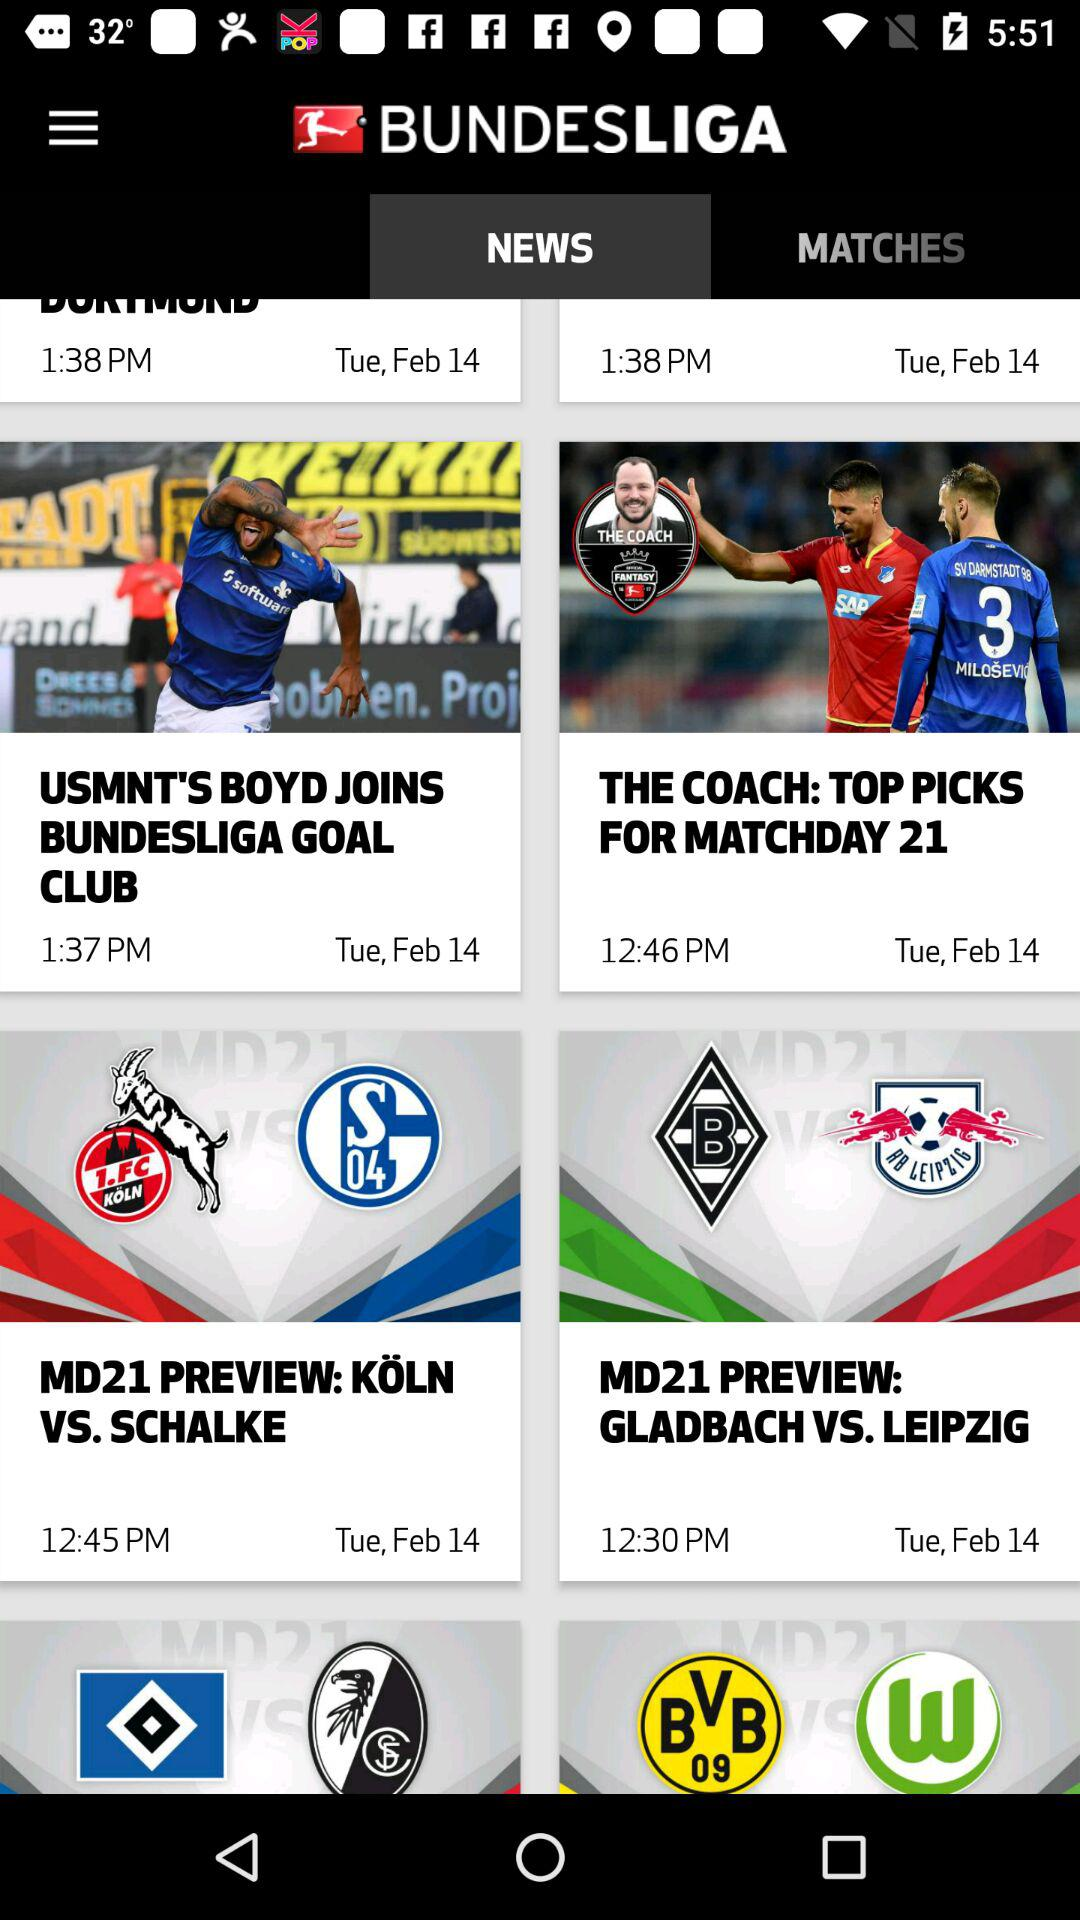Which news was published at 1:37 p.m.? The news published at 1:37 p.m. was "USMNT'S BOYD JOINS BUNDESLIGA GOAL CLUB". 